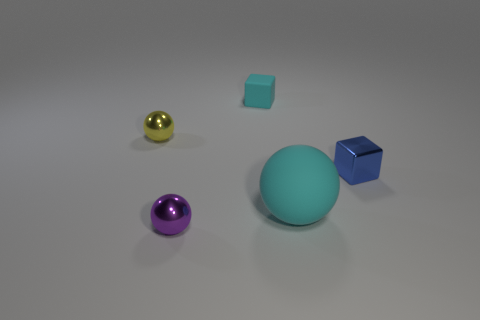What color is the small matte thing that is the same shape as the blue shiny thing?
Provide a short and direct response. Cyan. There is a yellow object that is the same shape as the tiny purple object; what is its size?
Give a very brief answer. Small. How many small things are in front of the yellow shiny sphere and left of the big matte thing?
Give a very brief answer. 1. How many metallic balls are in front of the sphere left of the tiny ball in front of the small yellow metallic thing?
Provide a succinct answer. 1. There is a rubber thing that is the same color as the big ball; what is its size?
Your answer should be compact. Small. What is the shape of the tiny blue thing?
Provide a succinct answer. Cube. What number of large spheres have the same material as the cyan cube?
Offer a terse response. 1. The other ball that is the same material as the yellow ball is what color?
Offer a terse response. Purple. Do the blue cube and the matte thing that is right of the cyan block have the same size?
Provide a short and direct response. No. What material is the ball in front of the cyan thing in front of the object on the left side of the purple object made of?
Your response must be concise. Metal. 